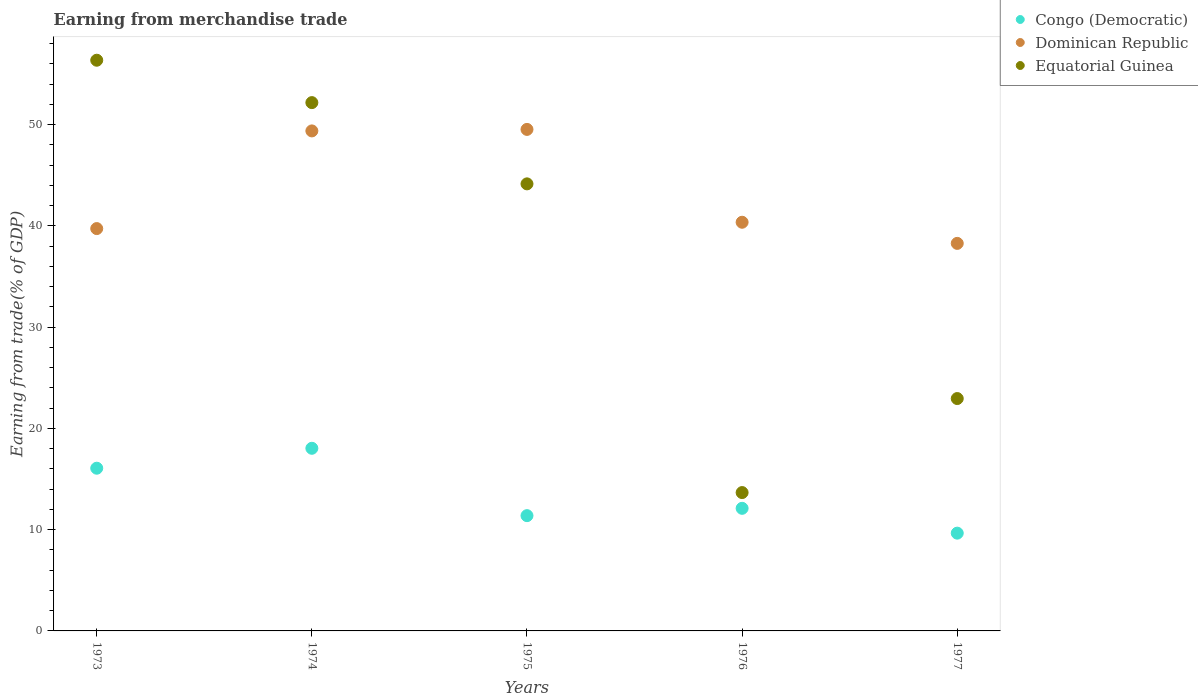How many different coloured dotlines are there?
Provide a succinct answer. 3. Is the number of dotlines equal to the number of legend labels?
Your answer should be compact. Yes. What is the earnings from trade in Dominican Republic in 1977?
Your answer should be very brief. 38.27. Across all years, what is the maximum earnings from trade in Congo (Democratic)?
Keep it short and to the point. 18.03. Across all years, what is the minimum earnings from trade in Equatorial Guinea?
Make the answer very short. 13.66. In which year was the earnings from trade in Dominican Republic maximum?
Give a very brief answer. 1975. What is the total earnings from trade in Dominican Republic in the graph?
Make the answer very short. 217.24. What is the difference between the earnings from trade in Dominican Republic in 1973 and that in 1977?
Provide a succinct answer. 1.46. What is the difference between the earnings from trade in Equatorial Guinea in 1973 and the earnings from trade in Dominican Republic in 1974?
Ensure brevity in your answer.  6.98. What is the average earnings from trade in Dominican Republic per year?
Your answer should be compact. 43.45. In the year 1976, what is the difference between the earnings from trade in Dominican Republic and earnings from trade in Equatorial Guinea?
Your answer should be very brief. 26.69. What is the ratio of the earnings from trade in Dominican Republic in 1976 to that in 1977?
Provide a succinct answer. 1.05. What is the difference between the highest and the second highest earnings from trade in Dominican Republic?
Make the answer very short. 0.15. What is the difference between the highest and the lowest earnings from trade in Congo (Democratic)?
Keep it short and to the point. 8.38. Is the sum of the earnings from trade in Equatorial Guinea in 1973 and 1977 greater than the maximum earnings from trade in Dominican Republic across all years?
Offer a very short reply. Yes. Is it the case that in every year, the sum of the earnings from trade in Equatorial Guinea and earnings from trade in Congo (Democratic)  is greater than the earnings from trade in Dominican Republic?
Your answer should be compact. No. Does the earnings from trade in Dominican Republic monotonically increase over the years?
Make the answer very short. No. Is the earnings from trade in Congo (Democratic) strictly less than the earnings from trade in Dominican Republic over the years?
Your response must be concise. Yes. How many dotlines are there?
Provide a short and direct response. 3. How many years are there in the graph?
Your response must be concise. 5. Does the graph contain grids?
Make the answer very short. No. Where does the legend appear in the graph?
Ensure brevity in your answer.  Top right. What is the title of the graph?
Give a very brief answer. Earning from merchandise trade. Does "Turkey" appear as one of the legend labels in the graph?
Make the answer very short. No. What is the label or title of the Y-axis?
Give a very brief answer. Earning from trade(% of GDP). What is the Earning from trade(% of GDP) in Congo (Democratic) in 1973?
Make the answer very short. 16.07. What is the Earning from trade(% of GDP) of Dominican Republic in 1973?
Your answer should be compact. 39.73. What is the Earning from trade(% of GDP) of Equatorial Guinea in 1973?
Provide a short and direct response. 56.35. What is the Earning from trade(% of GDP) of Congo (Democratic) in 1974?
Your answer should be very brief. 18.03. What is the Earning from trade(% of GDP) in Dominican Republic in 1974?
Keep it short and to the point. 49.37. What is the Earning from trade(% of GDP) in Equatorial Guinea in 1974?
Ensure brevity in your answer.  52.17. What is the Earning from trade(% of GDP) of Congo (Democratic) in 1975?
Make the answer very short. 11.38. What is the Earning from trade(% of GDP) of Dominican Republic in 1975?
Keep it short and to the point. 49.52. What is the Earning from trade(% of GDP) of Equatorial Guinea in 1975?
Ensure brevity in your answer.  44.14. What is the Earning from trade(% of GDP) in Congo (Democratic) in 1976?
Give a very brief answer. 12.11. What is the Earning from trade(% of GDP) of Dominican Republic in 1976?
Your answer should be very brief. 40.35. What is the Earning from trade(% of GDP) in Equatorial Guinea in 1976?
Offer a very short reply. 13.66. What is the Earning from trade(% of GDP) of Congo (Democratic) in 1977?
Your answer should be compact. 9.65. What is the Earning from trade(% of GDP) of Dominican Republic in 1977?
Your answer should be very brief. 38.27. What is the Earning from trade(% of GDP) in Equatorial Guinea in 1977?
Give a very brief answer. 22.95. Across all years, what is the maximum Earning from trade(% of GDP) of Congo (Democratic)?
Provide a short and direct response. 18.03. Across all years, what is the maximum Earning from trade(% of GDP) of Dominican Republic?
Make the answer very short. 49.52. Across all years, what is the maximum Earning from trade(% of GDP) of Equatorial Guinea?
Your response must be concise. 56.35. Across all years, what is the minimum Earning from trade(% of GDP) in Congo (Democratic)?
Your answer should be very brief. 9.65. Across all years, what is the minimum Earning from trade(% of GDP) of Dominican Republic?
Offer a very short reply. 38.27. Across all years, what is the minimum Earning from trade(% of GDP) of Equatorial Guinea?
Ensure brevity in your answer.  13.66. What is the total Earning from trade(% of GDP) of Congo (Democratic) in the graph?
Your answer should be compact. 67.24. What is the total Earning from trade(% of GDP) of Dominican Republic in the graph?
Your response must be concise. 217.24. What is the total Earning from trade(% of GDP) of Equatorial Guinea in the graph?
Your answer should be very brief. 189.27. What is the difference between the Earning from trade(% of GDP) in Congo (Democratic) in 1973 and that in 1974?
Provide a succinct answer. -1.97. What is the difference between the Earning from trade(% of GDP) in Dominican Republic in 1973 and that in 1974?
Give a very brief answer. -9.64. What is the difference between the Earning from trade(% of GDP) of Equatorial Guinea in 1973 and that in 1974?
Your response must be concise. 4.19. What is the difference between the Earning from trade(% of GDP) of Congo (Democratic) in 1973 and that in 1975?
Give a very brief answer. 4.68. What is the difference between the Earning from trade(% of GDP) in Dominican Republic in 1973 and that in 1975?
Provide a succinct answer. -9.79. What is the difference between the Earning from trade(% of GDP) of Equatorial Guinea in 1973 and that in 1975?
Keep it short and to the point. 12.21. What is the difference between the Earning from trade(% of GDP) of Congo (Democratic) in 1973 and that in 1976?
Your response must be concise. 3.96. What is the difference between the Earning from trade(% of GDP) in Dominican Republic in 1973 and that in 1976?
Ensure brevity in your answer.  -0.62. What is the difference between the Earning from trade(% of GDP) in Equatorial Guinea in 1973 and that in 1976?
Provide a short and direct response. 42.69. What is the difference between the Earning from trade(% of GDP) of Congo (Democratic) in 1973 and that in 1977?
Provide a short and direct response. 6.41. What is the difference between the Earning from trade(% of GDP) in Dominican Republic in 1973 and that in 1977?
Give a very brief answer. 1.46. What is the difference between the Earning from trade(% of GDP) of Equatorial Guinea in 1973 and that in 1977?
Give a very brief answer. 33.41. What is the difference between the Earning from trade(% of GDP) of Congo (Democratic) in 1974 and that in 1975?
Make the answer very short. 6.65. What is the difference between the Earning from trade(% of GDP) of Dominican Republic in 1974 and that in 1975?
Provide a short and direct response. -0.15. What is the difference between the Earning from trade(% of GDP) in Equatorial Guinea in 1974 and that in 1975?
Your response must be concise. 8.02. What is the difference between the Earning from trade(% of GDP) of Congo (Democratic) in 1974 and that in 1976?
Your answer should be very brief. 5.93. What is the difference between the Earning from trade(% of GDP) in Dominican Republic in 1974 and that in 1976?
Keep it short and to the point. 9.02. What is the difference between the Earning from trade(% of GDP) of Equatorial Guinea in 1974 and that in 1976?
Make the answer very short. 38.51. What is the difference between the Earning from trade(% of GDP) of Congo (Democratic) in 1974 and that in 1977?
Provide a succinct answer. 8.38. What is the difference between the Earning from trade(% of GDP) of Dominican Republic in 1974 and that in 1977?
Keep it short and to the point. 11.11. What is the difference between the Earning from trade(% of GDP) in Equatorial Guinea in 1974 and that in 1977?
Ensure brevity in your answer.  29.22. What is the difference between the Earning from trade(% of GDP) of Congo (Democratic) in 1975 and that in 1976?
Offer a very short reply. -0.72. What is the difference between the Earning from trade(% of GDP) of Dominican Republic in 1975 and that in 1976?
Offer a very short reply. 9.17. What is the difference between the Earning from trade(% of GDP) in Equatorial Guinea in 1975 and that in 1976?
Your answer should be very brief. 30.48. What is the difference between the Earning from trade(% of GDP) of Congo (Democratic) in 1975 and that in 1977?
Ensure brevity in your answer.  1.73. What is the difference between the Earning from trade(% of GDP) of Dominican Republic in 1975 and that in 1977?
Offer a terse response. 11.25. What is the difference between the Earning from trade(% of GDP) of Equatorial Guinea in 1975 and that in 1977?
Keep it short and to the point. 21.2. What is the difference between the Earning from trade(% of GDP) in Congo (Democratic) in 1976 and that in 1977?
Make the answer very short. 2.45. What is the difference between the Earning from trade(% of GDP) of Dominican Republic in 1976 and that in 1977?
Keep it short and to the point. 2.09. What is the difference between the Earning from trade(% of GDP) in Equatorial Guinea in 1976 and that in 1977?
Your answer should be compact. -9.28. What is the difference between the Earning from trade(% of GDP) of Congo (Democratic) in 1973 and the Earning from trade(% of GDP) of Dominican Republic in 1974?
Your response must be concise. -33.31. What is the difference between the Earning from trade(% of GDP) in Congo (Democratic) in 1973 and the Earning from trade(% of GDP) in Equatorial Guinea in 1974?
Your response must be concise. -36.1. What is the difference between the Earning from trade(% of GDP) in Dominican Republic in 1973 and the Earning from trade(% of GDP) in Equatorial Guinea in 1974?
Give a very brief answer. -12.44. What is the difference between the Earning from trade(% of GDP) of Congo (Democratic) in 1973 and the Earning from trade(% of GDP) of Dominican Republic in 1975?
Make the answer very short. -33.45. What is the difference between the Earning from trade(% of GDP) of Congo (Democratic) in 1973 and the Earning from trade(% of GDP) of Equatorial Guinea in 1975?
Provide a short and direct response. -28.08. What is the difference between the Earning from trade(% of GDP) of Dominican Republic in 1973 and the Earning from trade(% of GDP) of Equatorial Guinea in 1975?
Provide a short and direct response. -4.42. What is the difference between the Earning from trade(% of GDP) in Congo (Democratic) in 1973 and the Earning from trade(% of GDP) in Dominican Republic in 1976?
Your answer should be compact. -24.29. What is the difference between the Earning from trade(% of GDP) in Congo (Democratic) in 1973 and the Earning from trade(% of GDP) in Equatorial Guinea in 1976?
Your answer should be very brief. 2.41. What is the difference between the Earning from trade(% of GDP) of Dominican Republic in 1973 and the Earning from trade(% of GDP) of Equatorial Guinea in 1976?
Give a very brief answer. 26.07. What is the difference between the Earning from trade(% of GDP) in Congo (Democratic) in 1973 and the Earning from trade(% of GDP) in Dominican Republic in 1977?
Ensure brevity in your answer.  -22.2. What is the difference between the Earning from trade(% of GDP) in Congo (Democratic) in 1973 and the Earning from trade(% of GDP) in Equatorial Guinea in 1977?
Offer a terse response. -6.88. What is the difference between the Earning from trade(% of GDP) of Dominican Republic in 1973 and the Earning from trade(% of GDP) of Equatorial Guinea in 1977?
Offer a very short reply. 16.78. What is the difference between the Earning from trade(% of GDP) in Congo (Democratic) in 1974 and the Earning from trade(% of GDP) in Dominican Republic in 1975?
Your answer should be compact. -31.49. What is the difference between the Earning from trade(% of GDP) of Congo (Democratic) in 1974 and the Earning from trade(% of GDP) of Equatorial Guinea in 1975?
Provide a short and direct response. -26.11. What is the difference between the Earning from trade(% of GDP) of Dominican Republic in 1974 and the Earning from trade(% of GDP) of Equatorial Guinea in 1975?
Keep it short and to the point. 5.23. What is the difference between the Earning from trade(% of GDP) of Congo (Democratic) in 1974 and the Earning from trade(% of GDP) of Dominican Republic in 1976?
Give a very brief answer. -22.32. What is the difference between the Earning from trade(% of GDP) of Congo (Democratic) in 1974 and the Earning from trade(% of GDP) of Equatorial Guinea in 1976?
Provide a short and direct response. 4.37. What is the difference between the Earning from trade(% of GDP) of Dominican Republic in 1974 and the Earning from trade(% of GDP) of Equatorial Guinea in 1976?
Provide a succinct answer. 35.71. What is the difference between the Earning from trade(% of GDP) in Congo (Democratic) in 1974 and the Earning from trade(% of GDP) in Dominican Republic in 1977?
Provide a short and direct response. -20.23. What is the difference between the Earning from trade(% of GDP) in Congo (Democratic) in 1974 and the Earning from trade(% of GDP) in Equatorial Guinea in 1977?
Offer a very short reply. -4.91. What is the difference between the Earning from trade(% of GDP) of Dominican Republic in 1974 and the Earning from trade(% of GDP) of Equatorial Guinea in 1977?
Provide a short and direct response. 26.43. What is the difference between the Earning from trade(% of GDP) in Congo (Democratic) in 1975 and the Earning from trade(% of GDP) in Dominican Republic in 1976?
Provide a succinct answer. -28.97. What is the difference between the Earning from trade(% of GDP) of Congo (Democratic) in 1975 and the Earning from trade(% of GDP) of Equatorial Guinea in 1976?
Your response must be concise. -2.28. What is the difference between the Earning from trade(% of GDP) in Dominican Republic in 1975 and the Earning from trade(% of GDP) in Equatorial Guinea in 1976?
Keep it short and to the point. 35.86. What is the difference between the Earning from trade(% of GDP) of Congo (Democratic) in 1975 and the Earning from trade(% of GDP) of Dominican Republic in 1977?
Give a very brief answer. -26.88. What is the difference between the Earning from trade(% of GDP) in Congo (Democratic) in 1975 and the Earning from trade(% of GDP) in Equatorial Guinea in 1977?
Your response must be concise. -11.56. What is the difference between the Earning from trade(% of GDP) of Dominican Republic in 1975 and the Earning from trade(% of GDP) of Equatorial Guinea in 1977?
Provide a short and direct response. 26.58. What is the difference between the Earning from trade(% of GDP) of Congo (Democratic) in 1976 and the Earning from trade(% of GDP) of Dominican Republic in 1977?
Your answer should be very brief. -26.16. What is the difference between the Earning from trade(% of GDP) of Congo (Democratic) in 1976 and the Earning from trade(% of GDP) of Equatorial Guinea in 1977?
Your answer should be very brief. -10.84. What is the difference between the Earning from trade(% of GDP) of Dominican Republic in 1976 and the Earning from trade(% of GDP) of Equatorial Guinea in 1977?
Give a very brief answer. 17.41. What is the average Earning from trade(% of GDP) of Congo (Democratic) per year?
Offer a terse response. 13.45. What is the average Earning from trade(% of GDP) of Dominican Republic per year?
Provide a succinct answer. 43.45. What is the average Earning from trade(% of GDP) in Equatorial Guinea per year?
Your answer should be very brief. 37.85. In the year 1973, what is the difference between the Earning from trade(% of GDP) of Congo (Democratic) and Earning from trade(% of GDP) of Dominican Republic?
Make the answer very short. -23.66. In the year 1973, what is the difference between the Earning from trade(% of GDP) in Congo (Democratic) and Earning from trade(% of GDP) in Equatorial Guinea?
Provide a short and direct response. -40.29. In the year 1973, what is the difference between the Earning from trade(% of GDP) in Dominican Republic and Earning from trade(% of GDP) in Equatorial Guinea?
Give a very brief answer. -16.62. In the year 1974, what is the difference between the Earning from trade(% of GDP) in Congo (Democratic) and Earning from trade(% of GDP) in Dominican Republic?
Offer a terse response. -31.34. In the year 1974, what is the difference between the Earning from trade(% of GDP) of Congo (Democratic) and Earning from trade(% of GDP) of Equatorial Guinea?
Provide a short and direct response. -34.13. In the year 1974, what is the difference between the Earning from trade(% of GDP) of Dominican Republic and Earning from trade(% of GDP) of Equatorial Guinea?
Give a very brief answer. -2.79. In the year 1975, what is the difference between the Earning from trade(% of GDP) in Congo (Democratic) and Earning from trade(% of GDP) in Dominican Republic?
Provide a short and direct response. -38.14. In the year 1975, what is the difference between the Earning from trade(% of GDP) in Congo (Democratic) and Earning from trade(% of GDP) in Equatorial Guinea?
Provide a short and direct response. -32.76. In the year 1975, what is the difference between the Earning from trade(% of GDP) in Dominican Republic and Earning from trade(% of GDP) in Equatorial Guinea?
Offer a very short reply. 5.38. In the year 1976, what is the difference between the Earning from trade(% of GDP) of Congo (Democratic) and Earning from trade(% of GDP) of Dominican Republic?
Your answer should be very brief. -28.25. In the year 1976, what is the difference between the Earning from trade(% of GDP) in Congo (Democratic) and Earning from trade(% of GDP) in Equatorial Guinea?
Offer a very short reply. -1.56. In the year 1976, what is the difference between the Earning from trade(% of GDP) in Dominican Republic and Earning from trade(% of GDP) in Equatorial Guinea?
Ensure brevity in your answer.  26.69. In the year 1977, what is the difference between the Earning from trade(% of GDP) in Congo (Democratic) and Earning from trade(% of GDP) in Dominican Republic?
Provide a succinct answer. -28.61. In the year 1977, what is the difference between the Earning from trade(% of GDP) of Congo (Democratic) and Earning from trade(% of GDP) of Equatorial Guinea?
Your answer should be very brief. -13.29. In the year 1977, what is the difference between the Earning from trade(% of GDP) in Dominican Republic and Earning from trade(% of GDP) in Equatorial Guinea?
Provide a succinct answer. 15.32. What is the ratio of the Earning from trade(% of GDP) in Congo (Democratic) in 1973 to that in 1974?
Provide a short and direct response. 0.89. What is the ratio of the Earning from trade(% of GDP) in Dominican Republic in 1973 to that in 1974?
Ensure brevity in your answer.  0.8. What is the ratio of the Earning from trade(% of GDP) of Equatorial Guinea in 1973 to that in 1974?
Ensure brevity in your answer.  1.08. What is the ratio of the Earning from trade(% of GDP) of Congo (Democratic) in 1973 to that in 1975?
Ensure brevity in your answer.  1.41. What is the ratio of the Earning from trade(% of GDP) of Dominican Republic in 1973 to that in 1975?
Your response must be concise. 0.8. What is the ratio of the Earning from trade(% of GDP) in Equatorial Guinea in 1973 to that in 1975?
Ensure brevity in your answer.  1.28. What is the ratio of the Earning from trade(% of GDP) in Congo (Democratic) in 1973 to that in 1976?
Make the answer very short. 1.33. What is the ratio of the Earning from trade(% of GDP) in Dominican Republic in 1973 to that in 1976?
Your answer should be compact. 0.98. What is the ratio of the Earning from trade(% of GDP) in Equatorial Guinea in 1973 to that in 1976?
Offer a very short reply. 4.13. What is the ratio of the Earning from trade(% of GDP) in Congo (Democratic) in 1973 to that in 1977?
Provide a short and direct response. 1.66. What is the ratio of the Earning from trade(% of GDP) in Dominican Republic in 1973 to that in 1977?
Make the answer very short. 1.04. What is the ratio of the Earning from trade(% of GDP) in Equatorial Guinea in 1973 to that in 1977?
Your response must be concise. 2.46. What is the ratio of the Earning from trade(% of GDP) in Congo (Democratic) in 1974 to that in 1975?
Your response must be concise. 1.58. What is the ratio of the Earning from trade(% of GDP) of Equatorial Guinea in 1974 to that in 1975?
Your response must be concise. 1.18. What is the ratio of the Earning from trade(% of GDP) of Congo (Democratic) in 1974 to that in 1976?
Offer a very short reply. 1.49. What is the ratio of the Earning from trade(% of GDP) in Dominican Republic in 1974 to that in 1976?
Ensure brevity in your answer.  1.22. What is the ratio of the Earning from trade(% of GDP) of Equatorial Guinea in 1974 to that in 1976?
Make the answer very short. 3.82. What is the ratio of the Earning from trade(% of GDP) in Congo (Democratic) in 1974 to that in 1977?
Your response must be concise. 1.87. What is the ratio of the Earning from trade(% of GDP) in Dominican Republic in 1974 to that in 1977?
Give a very brief answer. 1.29. What is the ratio of the Earning from trade(% of GDP) of Equatorial Guinea in 1974 to that in 1977?
Keep it short and to the point. 2.27. What is the ratio of the Earning from trade(% of GDP) of Congo (Democratic) in 1975 to that in 1976?
Your response must be concise. 0.94. What is the ratio of the Earning from trade(% of GDP) in Dominican Republic in 1975 to that in 1976?
Provide a succinct answer. 1.23. What is the ratio of the Earning from trade(% of GDP) of Equatorial Guinea in 1975 to that in 1976?
Make the answer very short. 3.23. What is the ratio of the Earning from trade(% of GDP) of Congo (Democratic) in 1975 to that in 1977?
Your response must be concise. 1.18. What is the ratio of the Earning from trade(% of GDP) in Dominican Republic in 1975 to that in 1977?
Keep it short and to the point. 1.29. What is the ratio of the Earning from trade(% of GDP) in Equatorial Guinea in 1975 to that in 1977?
Give a very brief answer. 1.92. What is the ratio of the Earning from trade(% of GDP) in Congo (Democratic) in 1976 to that in 1977?
Provide a short and direct response. 1.25. What is the ratio of the Earning from trade(% of GDP) in Dominican Republic in 1976 to that in 1977?
Offer a terse response. 1.05. What is the ratio of the Earning from trade(% of GDP) in Equatorial Guinea in 1976 to that in 1977?
Keep it short and to the point. 0.6. What is the difference between the highest and the second highest Earning from trade(% of GDP) in Congo (Democratic)?
Keep it short and to the point. 1.97. What is the difference between the highest and the second highest Earning from trade(% of GDP) in Dominican Republic?
Make the answer very short. 0.15. What is the difference between the highest and the second highest Earning from trade(% of GDP) of Equatorial Guinea?
Offer a very short reply. 4.19. What is the difference between the highest and the lowest Earning from trade(% of GDP) of Congo (Democratic)?
Ensure brevity in your answer.  8.38. What is the difference between the highest and the lowest Earning from trade(% of GDP) of Dominican Republic?
Make the answer very short. 11.25. What is the difference between the highest and the lowest Earning from trade(% of GDP) in Equatorial Guinea?
Provide a short and direct response. 42.69. 